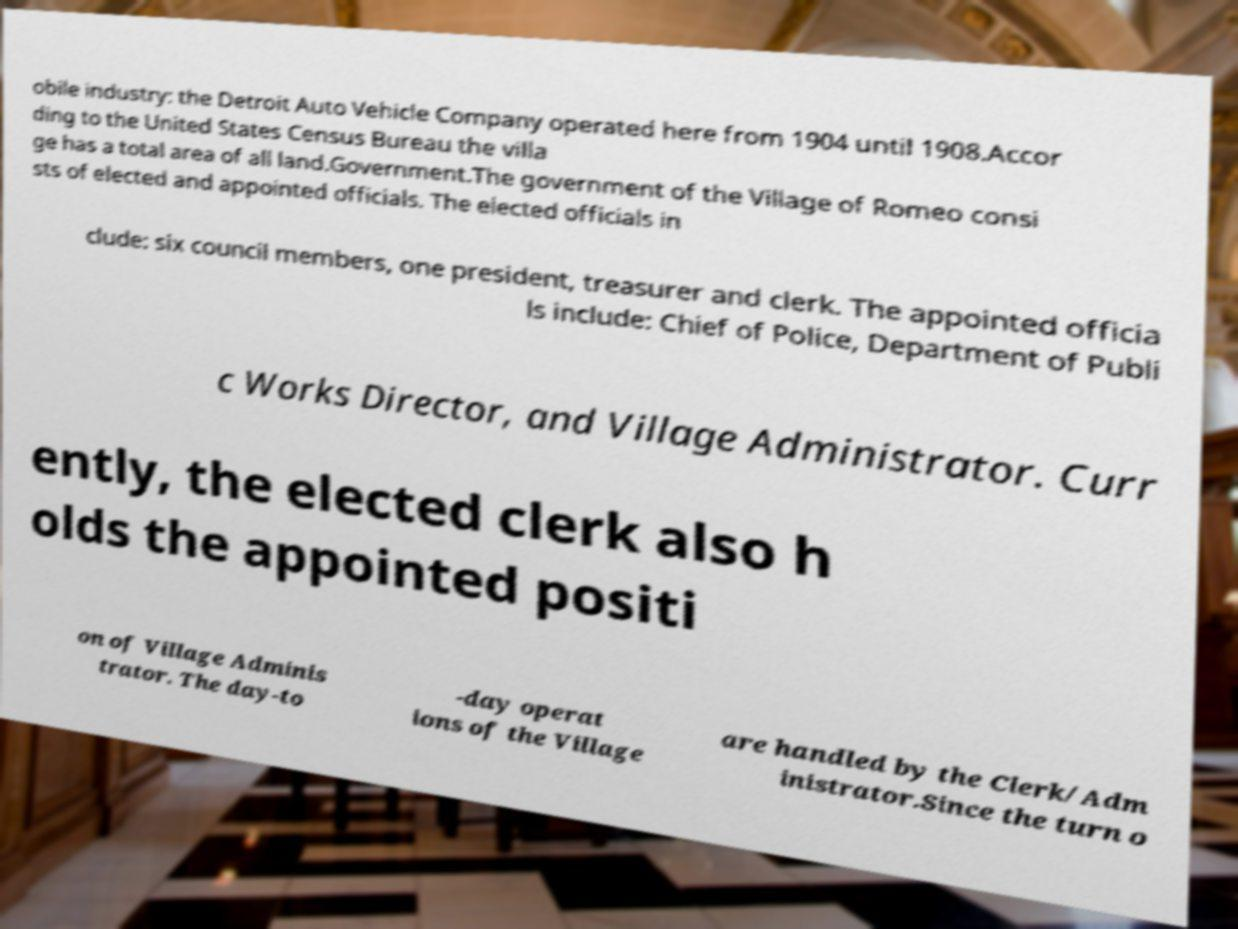Could you assist in decoding the text presented in this image and type it out clearly? obile industry: the Detroit Auto Vehicle Company operated here from 1904 until 1908.Accor ding to the United States Census Bureau the villa ge has a total area of all land.Government.The government of the Village of Romeo consi sts of elected and appointed officials. The elected officials in clude: six council members, one president, treasurer and clerk. The appointed officia ls include: Chief of Police, Department of Publi c Works Director, and Village Administrator. Curr ently, the elected clerk also h olds the appointed positi on of Village Adminis trator. The day-to -day operat ions of the Village are handled by the Clerk/Adm inistrator.Since the turn o 